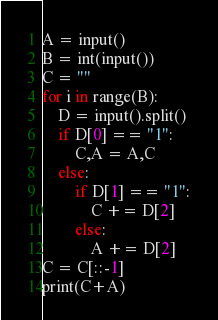Convert code to text. <code><loc_0><loc_0><loc_500><loc_500><_Python_>A = input()
B = int(input())
C = ""
for i in range(B):
    D = input().split()
    if D[0] == "1":
        C,A = A,C
    else:
        if D[1] == "1":
            C += D[2]
        else:
            A += D[2]
C = C[::-1]
print(C+A)</code> 